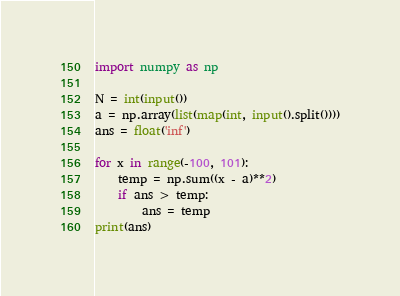<code> <loc_0><loc_0><loc_500><loc_500><_Python_>import numpy as np

N = int(input())
a = np.array(list(map(int, input().split())))
ans = float('inf')

for x in range(-100, 101):
    temp = np.sum((x - a)**2)
    if ans > temp:
        ans = temp
print(ans)</code> 